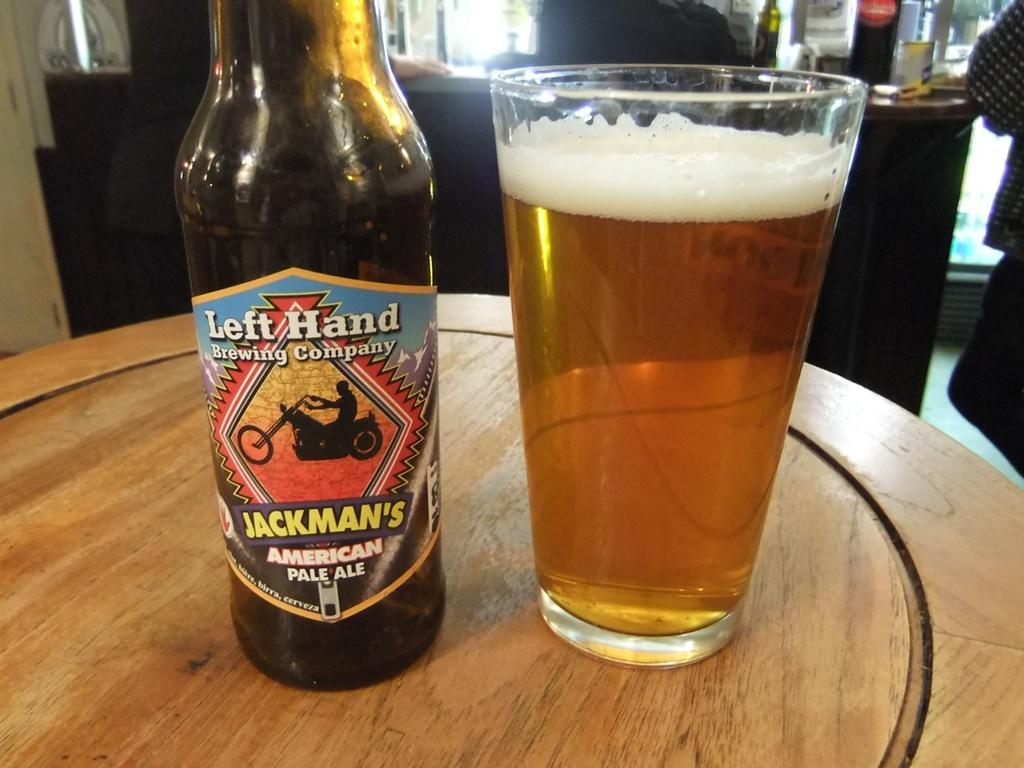<image>
Render a clear and concise summary of the photo. Glass bottle pale ale of Left Hand brewing company 